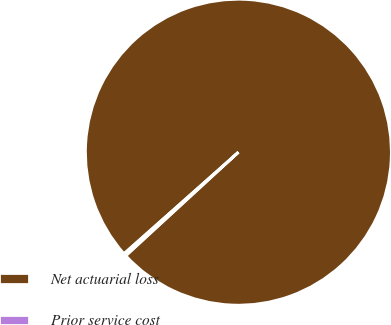Convert chart. <chart><loc_0><loc_0><loc_500><loc_500><pie_chart><fcel>Net actuarial loss<fcel>Prior service cost<nl><fcel>99.72%<fcel>0.28%<nl></chart> 